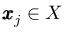<formula> <loc_0><loc_0><loc_500><loc_500>\pm b { x } _ { j } \in X</formula> 